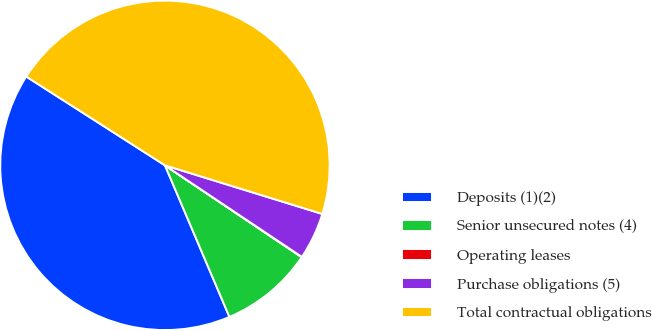Convert chart to OTSL. <chart><loc_0><loc_0><loc_500><loc_500><pie_chart><fcel>Deposits (1)(2)<fcel>Senior unsecured notes (4)<fcel>Operating leases<fcel>Purchase obligations (5)<fcel>Total contractual obligations<nl><fcel>40.46%<fcel>9.18%<fcel>0.04%<fcel>4.61%<fcel>45.71%<nl></chart> 